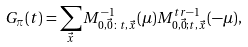Convert formula to latex. <formula><loc_0><loc_0><loc_500><loc_500>G _ { \pi } ( t ) = \sum _ { \vec { x } } M ^ { - 1 } _ { 0 , \vec { 0 } \colon t , \vec { x } } ( \mu ) M ^ { t r - 1 } _ { 0 , \vec { 0 } ; t , \vec { x } } ( - \mu ) ,</formula> 